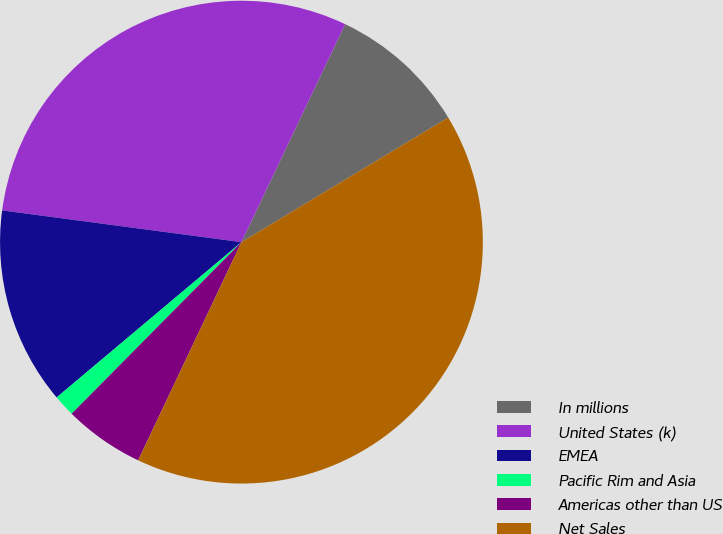<chart> <loc_0><loc_0><loc_500><loc_500><pie_chart><fcel>In millions<fcel>United States (k)<fcel>EMEA<fcel>Pacific Rim and Asia<fcel>Americas other than US<fcel>Net Sales<nl><fcel>9.3%<fcel>29.97%<fcel>13.22%<fcel>1.46%<fcel>5.38%<fcel>40.67%<nl></chart> 